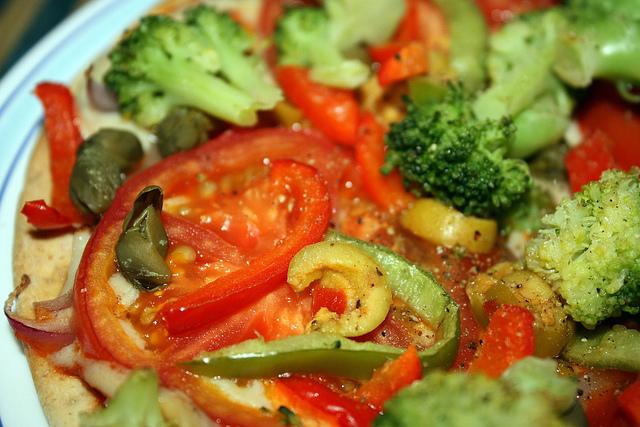Has the dish been cooked yet?
Be succinct. Yes. Does this look tasty?
Short answer required. Yes. Is this healthy?
Write a very short answer. Yes. Is there broccoli?
Give a very brief answer. Yes. 